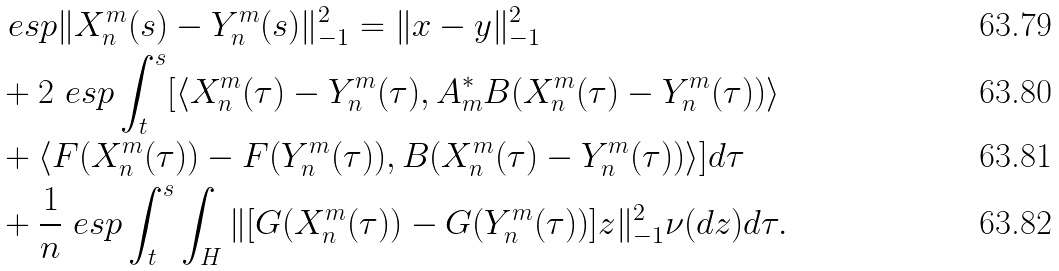Convert formula to latex. <formula><loc_0><loc_0><loc_500><loc_500>& \ e s p \| X _ { n } ^ { m } ( s ) - Y _ { n } ^ { m } ( s ) \| _ { - 1 } ^ { 2 } = \| x - y \| _ { - 1 } ^ { 2 } \\ & + 2 \ e s p \int _ { t } ^ { s } [ \langle X _ { n } ^ { m } ( \tau ) - Y _ { n } ^ { m } ( \tau ) , A _ { m } ^ { \ast } B ( X _ { n } ^ { m } ( \tau ) - Y _ { n } ^ { m } ( \tau ) ) \rangle \\ & + \langle F ( X _ { n } ^ { m } ( \tau ) ) - F ( Y _ { n } ^ { m } ( \tau ) ) , B ( X _ { n } ^ { m } ( \tau ) - Y _ { n } ^ { m } ( \tau ) ) \rangle ] d \tau \\ & + { \frac { 1 } { n } } \ e s p \int _ { t } ^ { s } \int _ { H } \| [ G ( X _ { n } ^ { m } ( \tau ) ) - G ( Y _ { n } ^ { m } ( \tau ) ) ] z \| _ { - 1 } ^ { 2 } \nu ( d z ) d \tau .</formula> 